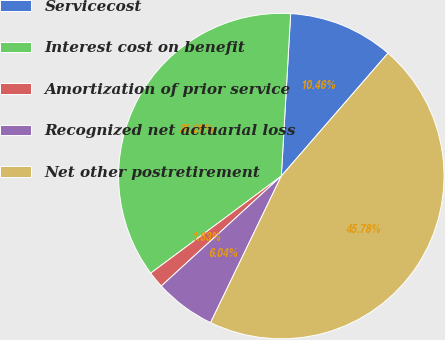<chart> <loc_0><loc_0><loc_500><loc_500><pie_chart><fcel>Servicecost<fcel>Interest cost on benefit<fcel>Amortization of prior service<fcel>Recognized net actuarial loss<fcel>Net other postretirement<nl><fcel>10.46%<fcel>36.09%<fcel>1.63%<fcel>6.04%<fcel>45.78%<nl></chart> 